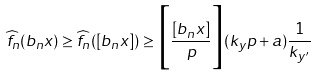<formula> <loc_0><loc_0><loc_500><loc_500>\widehat { f } _ { n } ( b _ { n } x ) \geq \widehat { f } _ { n } ( [ b _ { n } x ] ) \geq \Big { [ } \frac { [ b _ { n } x ] } { p } \Big { ] } ( k _ { y } p + a ) \frac { 1 } { k _ { y ^ { \prime } } }</formula> 